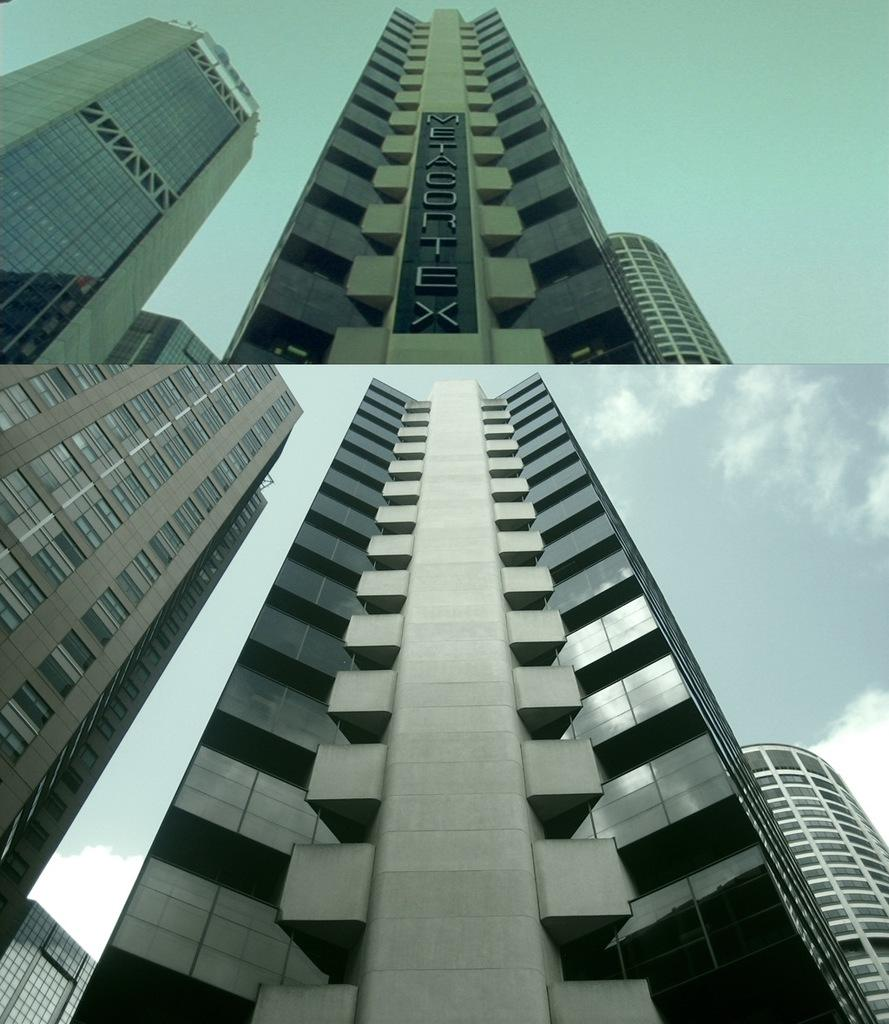What type of artwork is shown in the image? The image is a collage of two pictures. What can be seen in the collage? There are buildings in the collage. What is the tendency of the hat in the image? There is no hat present in the image. What is the zinc content of the buildings in the image? The zinc content of the buildings cannot be determined from the image. 